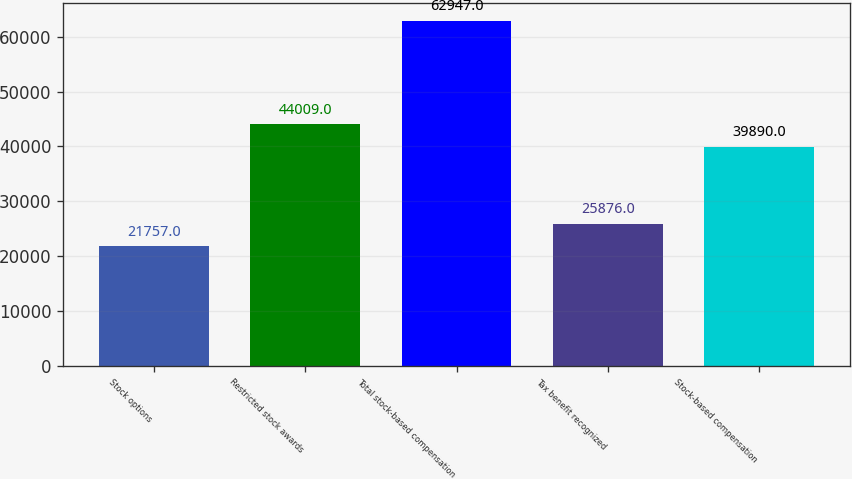<chart> <loc_0><loc_0><loc_500><loc_500><bar_chart><fcel>Stock options<fcel>Restricted stock awards<fcel>Total stock-based compensation<fcel>Tax benefit recognized<fcel>Stock-based compensation<nl><fcel>21757<fcel>44009<fcel>62947<fcel>25876<fcel>39890<nl></chart> 